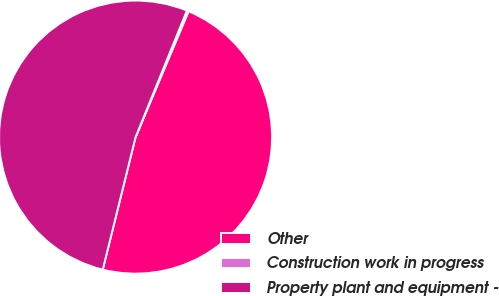<chart> <loc_0><loc_0><loc_500><loc_500><pie_chart><fcel>Other<fcel>Construction work in progress<fcel>Property plant and equipment -<nl><fcel>47.52%<fcel>0.21%<fcel>52.27%<nl></chart> 